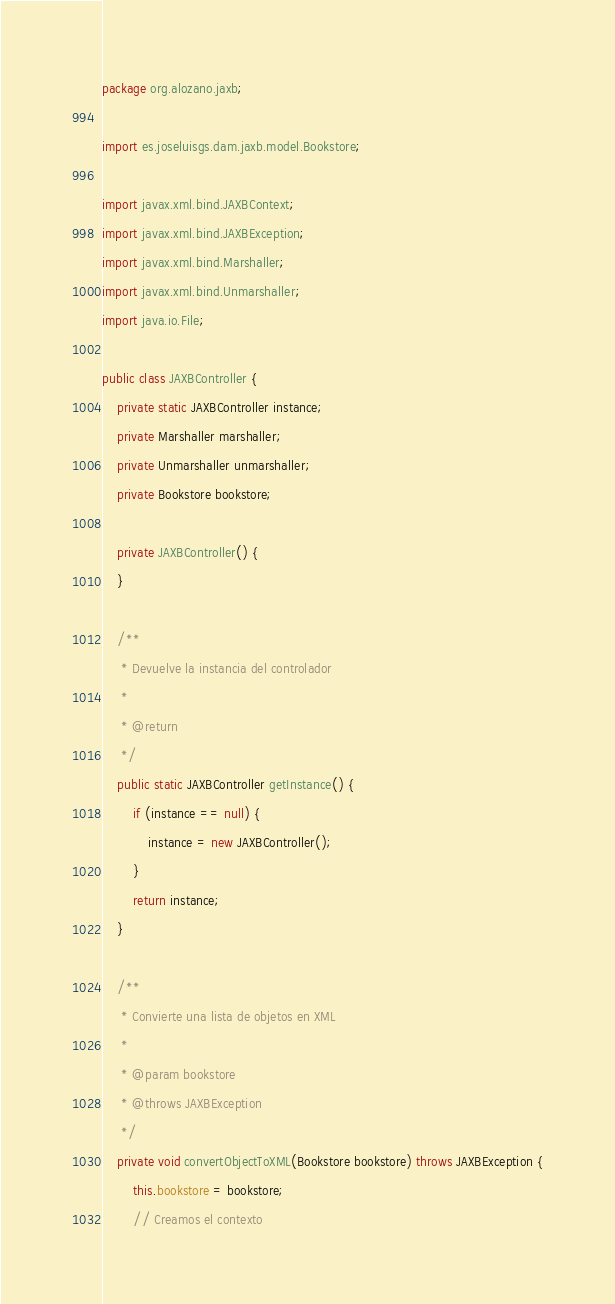Convert code to text. <code><loc_0><loc_0><loc_500><loc_500><_Java_>package org.alozano.jaxb;

import es.joseluisgs.dam.jaxb.model.Bookstore;

import javax.xml.bind.JAXBContext;
import javax.xml.bind.JAXBException;
import javax.xml.bind.Marshaller;
import javax.xml.bind.Unmarshaller;
import java.io.File;

public class JAXBController {
    private static JAXBController instance;
    private Marshaller marshaller;
    private Unmarshaller unmarshaller;
    private Bookstore bookstore;

    private JAXBController() {
    }

    /**
     * Devuelve la instancia del controlador
     *
     * @return
     */
    public static JAXBController getInstance() {
        if (instance == null) {
            instance = new JAXBController();
        }
        return instance;
    }

    /**
     * Convierte una lista de objetos en XML
     *
     * @param bookstore
     * @throws JAXBException
     */
    private void convertObjectToXML(Bookstore bookstore) throws JAXBException {
        this.bookstore = bookstore;
        // Creamos el contexto</code> 